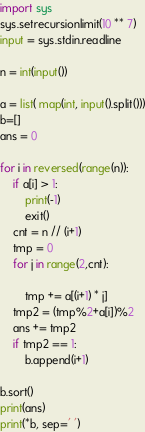<code> <loc_0><loc_0><loc_500><loc_500><_Python_>import sys
sys.setrecursionlimit(10 ** 7)
input = sys.stdin.readline

n = int(input())

a = list( map(int, input().split()))
b=[]
ans = 0

for i in reversed(range(n)):
    if a[i] > 1:
        print(-1)
        exit()
    cnt = n // (i+1)
    tmp = 0
    for j in range(2,cnt):

        tmp += a[(i+1) * j]
    tmp2 = (tmp%2+a[i])%2
    ans += tmp2
    if tmp2 == 1:
        b.append(i+1)

b.sort()
print(ans)
print(*b, sep=' ')</code> 